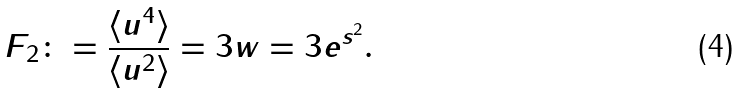<formula> <loc_0><loc_0><loc_500><loc_500>F _ { 2 } \colon = \frac { \langle u ^ { 4 } \rangle } { \langle u ^ { 2 } \rangle } = 3 w = 3 e ^ { s ^ { 2 } } .</formula> 